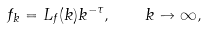<formula> <loc_0><loc_0><loc_500><loc_500>f _ { k } = L _ { f } ( k ) k ^ { - \tau } , \quad k \to \infty ,</formula> 